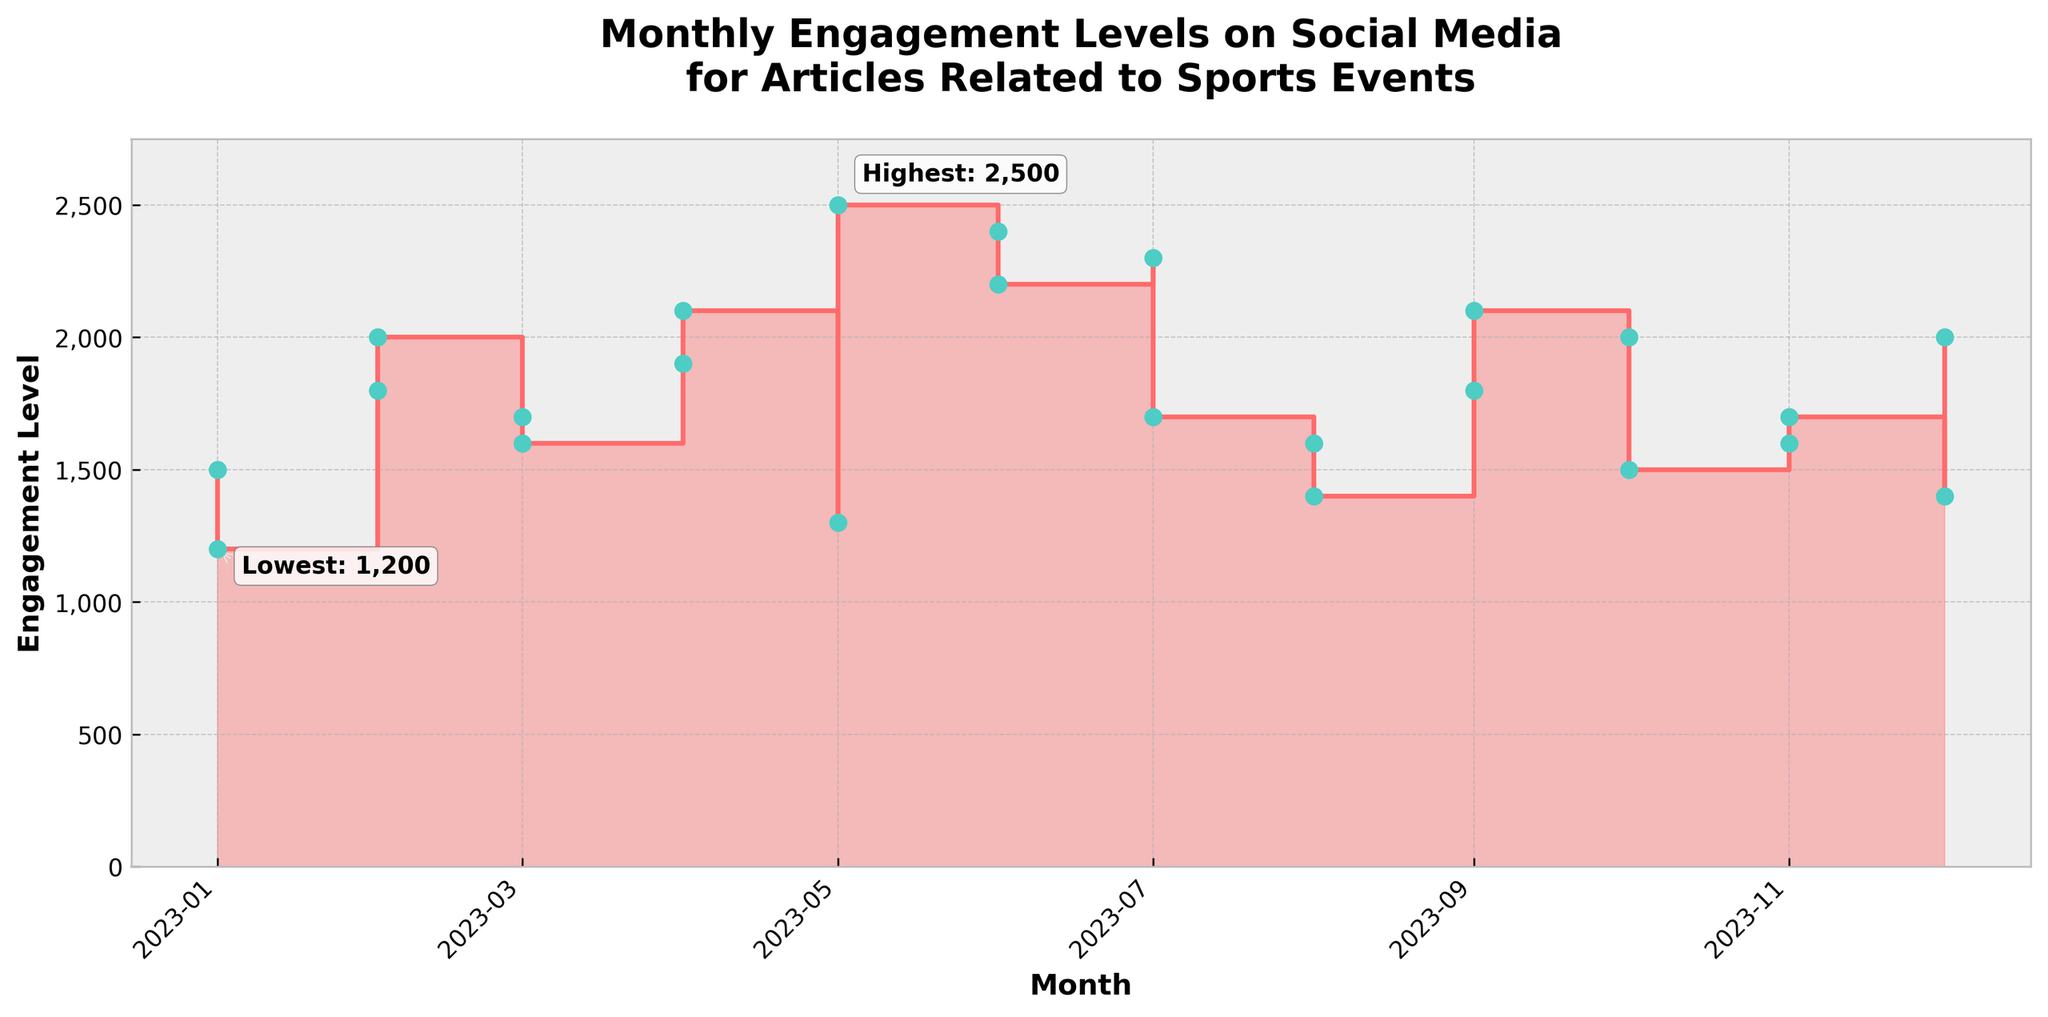What is the title of the plot? The title is written at the top of the plot, and it provides a summary of what the plot is about.
Answer: Monthly Engagement Levels on Social Media for Articles Related to Sports Events Which month has the highest engagement level? The highest engagement level can be identified by the peak point and the annotation on the plot. The annotation indicates the highest value and specifies the month.
Answer: May What is the engagement level for the WWE Finals Recap in October? Locate October on the x-axis, then trace upwards to find the engagement level for the WNBA Finals Recap. The engagement level is also labeled next to the corresponding dot.
Answer: 1500 Which month had the lowest engagement level and what was the value? The lowest engagement level is identified by the dip in the plot line and the annotation provided. This annotation specifies the month and value.
Answer: January, 1200 How did the engagement levels change from January to February? By looking at the plot, observe the step between January and February. The engagement level increased from January (1500) to February (1800).
Answer: Increased by 300 What major sports event article had an engagement level of 1700 in March? Trace March on the x-axis and find the engagement level of 1700. The corresponding article title is next to that point.
Answer: NCAA March Madness Preview Which article in June had a higher engagement level: 'French Open Finals' or 'Stanley Cup Final Review'? Look at June on the x-axis and compare the engagement levels of the two data points: the higher one represents the Stanley Cup Final Review.
Answer: Stanley Cup Final Review What is the average monthly engagement level from January to June? Calculate the average engagement level for the months January to June. Sum the engagement levels and divide by the number of months: (1500 + 1200 + 1800 + 2000 + 1700 + 1600 + 1900 + 2100 + 1300 + 2500)/(6 months).
Answer: 1933.33 How does the engagement level in July for 'Wimbledon Championships Recap' compare to August's 'US Open Tennis Preview'? Check the engagement levels for both months and compare: July has 2300, and August has 1600, indicating July has a higher engagement level.
Answer: Higher in July What trend is observed from September to November regarding football and basketball events? Observe the engagement levels on the plot from September to November. There is a general increase from September (1800 for US Open Tennis Finals) to November (1600 for NBA Season Preview and 1700 for MLS Cup Final).
Answer: Increasing trend 